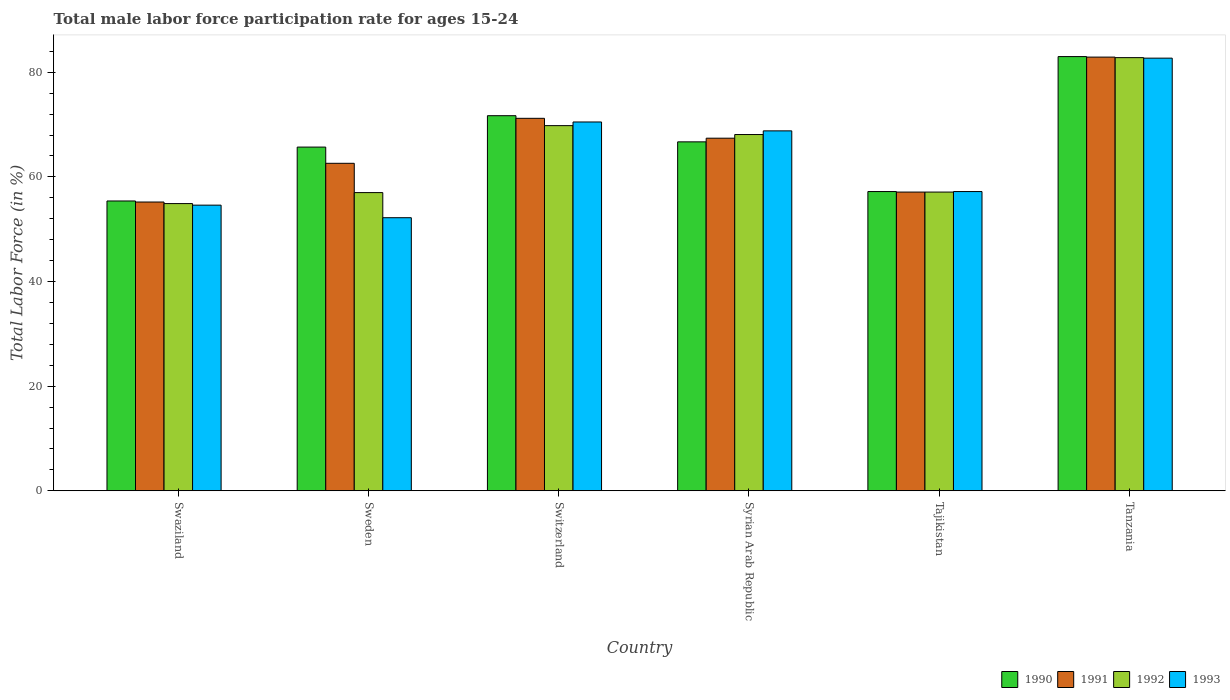What is the label of the 4th group of bars from the left?
Your answer should be very brief. Syrian Arab Republic. What is the male labor force participation rate in 1990 in Tanzania?
Offer a very short reply. 83. Across all countries, what is the maximum male labor force participation rate in 1992?
Make the answer very short. 82.8. Across all countries, what is the minimum male labor force participation rate in 1993?
Ensure brevity in your answer.  52.2. In which country was the male labor force participation rate in 1993 maximum?
Your answer should be compact. Tanzania. In which country was the male labor force participation rate in 1992 minimum?
Provide a short and direct response. Swaziland. What is the total male labor force participation rate in 1993 in the graph?
Offer a terse response. 386. What is the difference between the male labor force participation rate in 1991 in Swaziland and that in Tanzania?
Offer a terse response. -27.7. What is the difference between the male labor force participation rate in 1992 in Tajikistan and the male labor force participation rate in 1993 in Syrian Arab Republic?
Keep it short and to the point. -11.7. What is the average male labor force participation rate in 1990 per country?
Your answer should be very brief. 66.62. What is the difference between the male labor force participation rate of/in 1990 and male labor force participation rate of/in 1991 in Swaziland?
Offer a terse response. 0.2. What is the ratio of the male labor force participation rate in 1990 in Sweden to that in Tanzania?
Your response must be concise. 0.79. Is the male labor force participation rate in 1992 in Sweden less than that in Switzerland?
Provide a short and direct response. Yes. Is the difference between the male labor force participation rate in 1990 in Sweden and Switzerland greater than the difference between the male labor force participation rate in 1991 in Sweden and Switzerland?
Provide a short and direct response. Yes. What is the difference between the highest and the second highest male labor force participation rate in 1991?
Provide a short and direct response. 15.5. What is the difference between the highest and the lowest male labor force participation rate in 1992?
Offer a terse response. 27.9. In how many countries, is the male labor force participation rate in 1992 greater than the average male labor force participation rate in 1992 taken over all countries?
Provide a succinct answer. 3. What does the 3rd bar from the right in Tanzania represents?
Provide a short and direct response. 1991. Are all the bars in the graph horizontal?
Make the answer very short. No. How many countries are there in the graph?
Your answer should be very brief. 6. Are the values on the major ticks of Y-axis written in scientific E-notation?
Give a very brief answer. No. Does the graph contain any zero values?
Offer a very short reply. No. How many legend labels are there?
Your answer should be very brief. 4. How are the legend labels stacked?
Make the answer very short. Horizontal. What is the title of the graph?
Ensure brevity in your answer.  Total male labor force participation rate for ages 15-24. Does "1994" appear as one of the legend labels in the graph?
Your response must be concise. No. What is the Total Labor Force (in %) in 1990 in Swaziland?
Make the answer very short. 55.4. What is the Total Labor Force (in %) in 1991 in Swaziland?
Make the answer very short. 55.2. What is the Total Labor Force (in %) in 1992 in Swaziland?
Ensure brevity in your answer.  54.9. What is the Total Labor Force (in %) in 1993 in Swaziland?
Ensure brevity in your answer.  54.6. What is the Total Labor Force (in %) in 1990 in Sweden?
Offer a terse response. 65.7. What is the Total Labor Force (in %) of 1991 in Sweden?
Your answer should be very brief. 62.6. What is the Total Labor Force (in %) in 1992 in Sweden?
Your answer should be very brief. 57. What is the Total Labor Force (in %) in 1993 in Sweden?
Ensure brevity in your answer.  52.2. What is the Total Labor Force (in %) of 1990 in Switzerland?
Offer a terse response. 71.7. What is the Total Labor Force (in %) in 1991 in Switzerland?
Give a very brief answer. 71.2. What is the Total Labor Force (in %) of 1992 in Switzerland?
Offer a terse response. 69.8. What is the Total Labor Force (in %) of 1993 in Switzerland?
Offer a terse response. 70.5. What is the Total Labor Force (in %) in 1990 in Syrian Arab Republic?
Give a very brief answer. 66.7. What is the Total Labor Force (in %) of 1991 in Syrian Arab Republic?
Provide a short and direct response. 67.4. What is the Total Labor Force (in %) in 1992 in Syrian Arab Republic?
Make the answer very short. 68.1. What is the Total Labor Force (in %) of 1993 in Syrian Arab Republic?
Your response must be concise. 68.8. What is the Total Labor Force (in %) of 1990 in Tajikistan?
Your answer should be very brief. 57.2. What is the Total Labor Force (in %) in 1991 in Tajikistan?
Your answer should be very brief. 57.1. What is the Total Labor Force (in %) in 1992 in Tajikistan?
Ensure brevity in your answer.  57.1. What is the Total Labor Force (in %) in 1993 in Tajikistan?
Offer a very short reply. 57.2. What is the Total Labor Force (in %) of 1990 in Tanzania?
Your response must be concise. 83. What is the Total Labor Force (in %) of 1991 in Tanzania?
Give a very brief answer. 82.9. What is the Total Labor Force (in %) in 1992 in Tanzania?
Provide a short and direct response. 82.8. What is the Total Labor Force (in %) of 1993 in Tanzania?
Offer a terse response. 82.7. Across all countries, what is the maximum Total Labor Force (in %) of 1990?
Provide a succinct answer. 83. Across all countries, what is the maximum Total Labor Force (in %) of 1991?
Provide a short and direct response. 82.9. Across all countries, what is the maximum Total Labor Force (in %) of 1992?
Provide a succinct answer. 82.8. Across all countries, what is the maximum Total Labor Force (in %) of 1993?
Make the answer very short. 82.7. Across all countries, what is the minimum Total Labor Force (in %) of 1990?
Provide a short and direct response. 55.4. Across all countries, what is the minimum Total Labor Force (in %) of 1991?
Offer a very short reply. 55.2. Across all countries, what is the minimum Total Labor Force (in %) of 1992?
Ensure brevity in your answer.  54.9. Across all countries, what is the minimum Total Labor Force (in %) in 1993?
Your response must be concise. 52.2. What is the total Total Labor Force (in %) in 1990 in the graph?
Keep it short and to the point. 399.7. What is the total Total Labor Force (in %) of 1991 in the graph?
Provide a short and direct response. 396.4. What is the total Total Labor Force (in %) in 1992 in the graph?
Your answer should be compact. 389.7. What is the total Total Labor Force (in %) in 1993 in the graph?
Your answer should be very brief. 386. What is the difference between the Total Labor Force (in %) of 1990 in Swaziland and that in Sweden?
Give a very brief answer. -10.3. What is the difference between the Total Labor Force (in %) in 1993 in Swaziland and that in Sweden?
Provide a short and direct response. 2.4. What is the difference between the Total Labor Force (in %) of 1990 in Swaziland and that in Switzerland?
Offer a very short reply. -16.3. What is the difference between the Total Labor Force (in %) of 1991 in Swaziland and that in Switzerland?
Keep it short and to the point. -16. What is the difference between the Total Labor Force (in %) in 1992 in Swaziland and that in Switzerland?
Offer a terse response. -14.9. What is the difference between the Total Labor Force (in %) in 1993 in Swaziland and that in Switzerland?
Provide a succinct answer. -15.9. What is the difference between the Total Labor Force (in %) of 1990 in Swaziland and that in Syrian Arab Republic?
Offer a very short reply. -11.3. What is the difference between the Total Labor Force (in %) of 1991 in Swaziland and that in Syrian Arab Republic?
Your response must be concise. -12.2. What is the difference between the Total Labor Force (in %) of 1992 in Swaziland and that in Syrian Arab Republic?
Your answer should be compact. -13.2. What is the difference between the Total Labor Force (in %) in 1990 in Swaziland and that in Tajikistan?
Provide a short and direct response. -1.8. What is the difference between the Total Labor Force (in %) of 1991 in Swaziland and that in Tajikistan?
Provide a succinct answer. -1.9. What is the difference between the Total Labor Force (in %) in 1992 in Swaziland and that in Tajikistan?
Offer a very short reply. -2.2. What is the difference between the Total Labor Force (in %) of 1993 in Swaziland and that in Tajikistan?
Offer a very short reply. -2.6. What is the difference between the Total Labor Force (in %) in 1990 in Swaziland and that in Tanzania?
Offer a very short reply. -27.6. What is the difference between the Total Labor Force (in %) of 1991 in Swaziland and that in Tanzania?
Offer a terse response. -27.7. What is the difference between the Total Labor Force (in %) of 1992 in Swaziland and that in Tanzania?
Provide a succinct answer. -27.9. What is the difference between the Total Labor Force (in %) of 1993 in Swaziland and that in Tanzania?
Keep it short and to the point. -28.1. What is the difference between the Total Labor Force (in %) in 1992 in Sweden and that in Switzerland?
Keep it short and to the point. -12.8. What is the difference between the Total Labor Force (in %) of 1993 in Sweden and that in Switzerland?
Offer a very short reply. -18.3. What is the difference between the Total Labor Force (in %) of 1990 in Sweden and that in Syrian Arab Republic?
Offer a terse response. -1. What is the difference between the Total Labor Force (in %) of 1991 in Sweden and that in Syrian Arab Republic?
Offer a very short reply. -4.8. What is the difference between the Total Labor Force (in %) of 1993 in Sweden and that in Syrian Arab Republic?
Ensure brevity in your answer.  -16.6. What is the difference between the Total Labor Force (in %) of 1991 in Sweden and that in Tajikistan?
Offer a terse response. 5.5. What is the difference between the Total Labor Force (in %) in 1992 in Sweden and that in Tajikistan?
Your response must be concise. -0.1. What is the difference between the Total Labor Force (in %) in 1990 in Sweden and that in Tanzania?
Offer a very short reply. -17.3. What is the difference between the Total Labor Force (in %) in 1991 in Sweden and that in Tanzania?
Ensure brevity in your answer.  -20.3. What is the difference between the Total Labor Force (in %) of 1992 in Sweden and that in Tanzania?
Your answer should be compact. -25.8. What is the difference between the Total Labor Force (in %) in 1993 in Sweden and that in Tanzania?
Make the answer very short. -30.5. What is the difference between the Total Labor Force (in %) in 1990 in Switzerland and that in Tajikistan?
Give a very brief answer. 14.5. What is the difference between the Total Labor Force (in %) in 1992 in Switzerland and that in Tajikistan?
Offer a terse response. 12.7. What is the difference between the Total Labor Force (in %) in 1992 in Switzerland and that in Tanzania?
Offer a very short reply. -13. What is the difference between the Total Labor Force (in %) of 1990 in Syrian Arab Republic and that in Tanzania?
Your answer should be compact. -16.3. What is the difference between the Total Labor Force (in %) in 1991 in Syrian Arab Republic and that in Tanzania?
Give a very brief answer. -15.5. What is the difference between the Total Labor Force (in %) of 1992 in Syrian Arab Republic and that in Tanzania?
Offer a terse response. -14.7. What is the difference between the Total Labor Force (in %) of 1990 in Tajikistan and that in Tanzania?
Provide a succinct answer. -25.8. What is the difference between the Total Labor Force (in %) in 1991 in Tajikistan and that in Tanzania?
Keep it short and to the point. -25.8. What is the difference between the Total Labor Force (in %) of 1992 in Tajikistan and that in Tanzania?
Make the answer very short. -25.7. What is the difference between the Total Labor Force (in %) of 1993 in Tajikistan and that in Tanzania?
Provide a succinct answer. -25.5. What is the difference between the Total Labor Force (in %) in 1991 in Swaziland and the Total Labor Force (in %) in 1992 in Sweden?
Your answer should be very brief. -1.8. What is the difference between the Total Labor Force (in %) in 1991 in Swaziland and the Total Labor Force (in %) in 1993 in Sweden?
Keep it short and to the point. 3. What is the difference between the Total Labor Force (in %) in 1990 in Swaziland and the Total Labor Force (in %) in 1991 in Switzerland?
Offer a very short reply. -15.8. What is the difference between the Total Labor Force (in %) of 1990 in Swaziland and the Total Labor Force (in %) of 1992 in Switzerland?
Offer a terse response. -14.4. What is the difference between the Total Labor Force (in %) in 1990 in Swaziland and the Total Labor Force (in %) in 1993 in Switzerland?
Give a very brief answer. -15.1. What is the difference between the Total Labor Force (in %) of 1991 in Swaziland and the Total Labor Force (in %) of 1992 in Switzerland?
Your answer should be compact. -14.6. What is the difference between the Total Labor Force (in %) of 1991 in Swaziland and the Total Labor Force (in %) of 1993 in Switzerland?
Your response must be concise. -15.3. What is the difference between the Total Labor Force (in %) in 1992 in Swaziland and the Total Labor Force (in %) in 1993 in Switzerland?
Provide a succinct answer. -15.6. What is the difference between the Total Labor Force (in %) of 1990 in Swaziland and the Total Labor Force (in %) of 1991 in Syrian Arab Republic?
Give a very brief answer. -12. What is the difference between the Total Labor Force (in %) in 1992 in Swaziland and the Total Labor Force (in %) in 1993 in Syrian Arab Republic?
Keep it short and to the point. -13.9. What is the difference between the Total Labor Force (in %) in 1990 in Swaziland and the Total Labor Force (in %) in 1992 in Tajikistan?
Provide a succinct answer. -1.7. What is the difference between the Total Labor Force (in %) of 1990 in Swaziland and the Total Labor Force (in %) of 1993 in Tajikistan?
Make the answer very short. -1.8. What is the difference between the Total Labor Force (in %) of 1992 in Swaziland and the Total Labor Force (in %) of 1993 in Tajikistan?
Your response must be concise. -2.3. What is the difference between the Total Labor Force (in %) in 1990 in Swaziland and the Total Labor Force (in %) in 1991 in Tanzania?
Your answer should be compact. -27.5. What is the difference between the Total Labor Force (in %) of 1990 in Swaziland and the Total Labor Force (in %) of 1992 in Tanzania?
Ensure brevity in your answer.  -27.4. What is the difference between the Total Labor Force (in %) in 1990 in Swaziland and the Total Labor Force (in %) in 1993 in Tanzania?
Keep it short and to the point. -27.3. What is the difference between the Total Labor Force (in %) in 1991 in Swaziland and the Total Labor Force (in %) in 1992 in Tanzania?
Your answer should be compact. -27.6. What is the difference between the Total Labor Force (in %) of 1991 in Swaziland and the Total Labor Force (in %) of 1993 in Tanzania?
Provide a short and direct response. -27.5. What is the difference between the Total Labor Force (in %) in 1992 in Swaziland and the Total Labor Force (in %) in 1993 in Tanzania?
Your response must be concise. -27.8. What is the difference between the Total Labor Force (in %) in 1990 in Sweden and the Total Labor Force (in %) in 1991 in Switzerland?
Your answer should be very brief. -5.5. What is the difference between the Total Labor Force (in %) in 1990 in Sweden and the Total Labor Force (in %) in 1992 in Switzerland?
Ensure brevity in your answer.  -4.1. What is the difference between the Total Labor Force (in %) in 1990 in Sweden and the Total Labor Force (in %) in 1993 in Switzerland?
Your response must be concise. -4.8. What is the difference between the Total Labor Force (in %) in 1991 in Sweden and the Total Labor Force (in %) in 1992 in Switzerland?
Make the answer very short. -7.2. What is the difference between the Total Labor Force (in %) of 1991 in Sweden and the Total Labor Force (in %) of 1993 in Switzerland?
Make the answer very short. -7.9. What is the difference between the Total Labor Force (in %) in 1990 in Sweden and the Total Labor Force (in %) in 1993 in Syrian Arab Republic?
Make the answer very short. -3.1. What is the difference between the Total Labor Force (in %) in 1991 in Sweden and the Total Labor Force (in %) in 1992 in Syrian Arab Republic?
Your response must be concise. -5.5. What is the difference between the Total Labor Force (in %) in 1992 in Sweden and the Total Labor Force (in %) in 1993 in Syrian Arab Republic?
Provide a short and direct response. -11.8. What is the difference between the Total Labor Force (in %) in 1990 in Sweden and the Total Labor Force (in %) in 1991 in Tajikistan?
Your response must be concise. 8.6. What is the difference between the Total Labor Force (in %) of 1990 in Sweden and the Total Labor Force (in %) of 1992 in Tajikistan?
Ensure brevity in your answer.  8.6. What is the difference between the Total Labor Force (in %) of 1990 in Sweden and the Total Labor Force (in %) of 1993 in Tajikistan?
Give a very brief answer. 8.5. What is the difference between the Total Labor Force (in %) of 1991 in Sweden and the Total Labor Force (in %) of 1992 in Tajikistan?
Provide a short and direct response. 5.5. What is the difference between the Total Labor Force (in %) of 1992 in Sweden and the Total Labor Force (in %) of 1993 in Tajikistan?
Give a very brief answer. -0.2. What is the difference between the Total Labor Force (in %) of 1990 in Sweden and the Total Labor Force (in %) of 1991 in Tanzania?
Offer a terse response. -17.2. What is the difference between the Total Labor Force (in %) in 1990 in Sweden and the Total Labor Force (in %) in 1992 in Tanzania?
Keep it short and to the point. -17.1. What is the difference between the Total Labor Force (in %) of 1991 in Sweden and the Total Labor Force (in %) of 1992 in Tanzania?
Keep it short and to the point. -20.2. What is the difference between the Total Labor Force (in %) in 1991 in Sweden and the Total Labor Force (in %) in 1993 in Tanzania?
Your answer should be very brief. -20.1. What is the difference between the Total Labor Force (in %) of 1992 in Sweden and the Total Labor Force (in %) of 1993 in Tanzania?
Your response must be concise. -25.7. What is the difference between the Total Labor Force (in %) of 1990 in Switzerland and the Total Labor Force (in %) of 1992 in Syrian Arab Republic?
Your response must be concise. 3.6. What is the difference between the Total Labor Force (in %) in 1991 in Switzerland and the Total Labor Force (in %) in 1993 in Syrian Arab Republic?
Provide a short and direct response. 2.4. What is the difference between the Total Labor Force (in %) of 1990 in Switzerland and the Total Labor Force (in %) of 1991 in Tajikistan?
Ensure brevity in your answer.  14.6. What is the difference between the Total Labor Force (in %) of 1990 in Switzerland and the Total Labor Force (in %) of 1993 in Tajikistan?
Keep it short and to the point. 14.5. What is the difference between the Total Labor Force (in %) of 1992 in Switzerland and the Total Labor Force (in %) of 1993 in Tajikistan?
Make the answer very short. 12.6. What is the difference between the Total Labor Force (in %) in 1990 in Switzerland and the Total Labor Force (in %) in 1991 in Tanzania?
Your answer should be compact. -11.2. What is the difference between the Total Labor Force (in %) in 1990 in Syrian Arab Republic and the Total Labor Force (in %) in 1991 in Tajikistan?
Provide a succinct answer. 9.6. What is the difference between the Total Labor Force (in %) of 1990 in Syrian Arab Republic and the Total Labor Force (in %) of 1993 in Tajikistan?
Your response must be concise. 9.5. What is the difference between the Total Labor Force (in %) of 1991 in Syrian Arab Republic and the Total Labor Force (in %) of 1993 in Tajikistan?
Provide a short and direct response. 10.2. What is the difference between the Total Labor Force (in %) of 1990 in Syrian Arab Republic and the Total Labor Force (in %) of 1991 in Tanzania?
Give a very brief answer. -16.2. What is the difference between the Total Labor Force (in %) of 1990 in Syrian Arab Republic and the Total Labor Force (in %) of 1992 in Tanzania?
Ensure brevity in your answer.  -16.1. What is the difference between the Total Labor Force (in %) of 1991 in Syrian Arab Republic and the Total Labor Force (in %) of 1992 in Tanzania?
Your answer should be very brief. -15.4. What is the difference between the Total Labor Force (in %) in 1991 in Syrian Arab Republic and the Total Labor Force (in %) in 1993 in Tanzania?
Your response must be concise. -15.3. What is the difference between the Total Labor Force (in %) in 1992 in Syrian Arab Republic and the Total Labor Force (in %) in 1993 in Tanzania?
Offer a very short reply. -14.6. What is the difference between the Total Labor Force (in %) of 1990 in Tajikistan and the Total Labor Force (in %) of 1991 in Tanzania?
Offer a very short reply. -25.7. What is the difference between the Total Labor Force (in %) of 1990 in Tajikistan and the Total Labor Force (in %) of 1992 in Tanzania?
Your answer should be compact. -25.6. What is the difference between the Total Labor Force (in %) in 1990 in Tajikistan and the Total Labor Force (in %) in 1993 in Tanzania?
Offer a terse response. -25.5. What is the difference between the Total Labor Force (in %) in 1991 in Tajikistan and the Total Labor Force (in %) in 1992 in Tanzania?
Your response must be concise. -25.7. What is the difference between the Total Labor Force (in %) in 1991 in Tajikistan and the Total Labor Force (in %) in 1993 in Tanzania?
Provide a short and direct response. -25.6. What is the difference between the Total Labor Force (in %) of 1992 in Tajikistan and the Total Labor Force (in %) of 1993 in Tanzania?
Offer a very short reply. -25.6. What is the average Total Labor Force (in %) in 1990 per country?
Ensure brevity in your answer.  66.62. What is the average Total Labor Force (in %) in 1991 per country?
Offer a terse response. 66.07. What is the average Total Labor Force (in %) of 1992 per country?
Provide a short and direct response. 64.95. What is the average Total Labor Force (in %) of 1993 per country?
Offer a very short reply. 64.33. What is the difference between the Total Labor Force (in %) of 1990 and Total Labor Force (in %) of 1992 in Swaziland?
Your answer should be very brief. 0.5. What is the difference between the Total Labor Force (in %) in 1991 and Total Labor Force (in %) in 1993 in Swaziland?
Make the answer very short. 0.6. What is the difference between the Total Labor Force (in %) of 1990 and Total Labor Force (in %) of 1991 in Sweden?
Ensure brevity in your answer.  3.1. What is the difference between the Total Labor Force (in %) in 1990 and Total Labor Force (in %) in 1992 in Sweden?
Your response must be concise. 8.7. What is the difference between the Total Labor Force (in %) of 1991 and Total Labor Force (in %) of 1993 in Sweden?
Provide a succinct answer. 10.4. What is the difference between the Total Labor Force (in %) in 1990 and Total Labor Force (in %) in 1992 in Switzerland?
Provide a short and direct response. 1.9. What is the difference between the Total Labor Force (in %) in 1990 and Total Labor Force (in %) in 1993 in Switzerland?
Offer a terse response. 1.2. What is the difference between the Total Labor Force (in %) in 1991 and Total Labor Force (in %) in 1993 in Switzerland?
Keep it short and to the point. 0.7. What is the difference between the Total Labor Force (in %) of 1990 and Total Labor Force (in %) of 1993 in Syrian Arab Republic?
Offer a very short reply. -2.1. What is the difference between the Total Labor Force (in %) in 1992 and Total Labor Force (in %) in 1993 in Syrian Arab Republic?
Your answer should be compact. -0.7. What is the difference between the Total Labor Force (in %) in 1990 and Total Labor Force (in %) in 1991 in Tajikistan?
Your response must be concise. 0.1. What is the difference between the Total Labor Force (in %) in 1991 and Total Labor Force (in %) in 1992 in Tajikistan?
Provide a succinct answer. 0. What is the difference between the Total Labor Force (in %) in 1992 and Total Labor Force (in %) in 1993 in Tajikistan?
Give a very brief answer. -0.1. What is the difference between the Total Labor Force (in %) of 1990 and Total Labor Force (in %) of 1991 in Tanzania?
Your answer should be compact. 0.1. What is the difference between the Total Labor Force (in %) in 1991 and Total Labor Force (in %) in 1993 in Tanzania?
Provide a short and direct response. 0.2. What is the ratio of the Total Labor Force (in %) of 1990 in Swaziland to that in Sweden?
Keep it short and to the point. 0.84. What is the ratio of the Total Labor Force (in %) of 1991 in Swaziland to that in Sweden?
Ensure brevity in your answer.  0.88. What is the ratio of the Total Labor Force (in %) in 1992 in Swaziland to that in Sweden?
Provide a short and direct response. 0.96. What is the ratio of the Total Labor Force (in %) of 1993 in Swaziland to that in Sweden?
Offer a very short reply. 1.05. What is the ratio of the Total Labor Force (in %) in 1990 in Swaziland to that in Switzerland?
Provide a succinct answer. 0.77. What is the ratio of the Total Labor Force (in %) in 1991 in Swaziland to that in Switzerland?
Ensure brevity in your answer.  0.78. What is the ratio of the Total Labor Force (in %) in 1992 in Swaziland to that in Switzerland?
Provide a succinct answer. 0.79. What is the ratio of the Total Labor Force (in %) in 1993 in Swaziland to that in Switzerland?
Give a very brief answer. 0.77. What is the ratio of the Total Labor Force (in %) in 1990 in Swaziland to that in Syrian Arab Republic?
Keep it short and to the point. 0.83. What is the ratio of the Total Labor Force (in %) of 1991 in Swaziland to that in Syrian Arab Republic?
Provide a short and direct response. 0.82. What is the ratio of the Total Labor Force (in %) in 1992 in Swaziland to that in Syrian Arab Republic?
Provide a short and direct response. 0.81. What is the ratio of the Total Labor Force (in %) in 1993 in Swaziland to that in Syrian Arab Republic?
Give a very brief answer. 0.79. What is the ratio of the Total Labor Force (in %) of 1990 in Swaziland to that in Tajikistan?
Your answer should be very brief. 0.97. What is the ratio of the Total Labor Force (in %) in 1991 in Swaziland to that in Tajikistan?
Offer a terse response. 0.97. What is the ratio of the Total Labor Force (in %) in 1992 in Swaziland to that in Tajikistan?
Provide a succinct answer. 0.96. What is the ratio of the Total Labor Force (in %) in 1993 in Swaziland to that in Tajikistan?
Offer a terse response. 0.95. What is the ratio of the Total Labor Force (in %) in 1990 in Swaziland to that in Tanzania?
Offer a very short reply. 0.67. What is the ratio of the Total Labor Force (in %) of 1991 in Swaziland to that in Tanzania?
Offer a very short reply. 0.67. What is the ratio of the Total Labor Force (in %) of 1992 in Swaziland to that in Tanzania?
Your answer should be compact. 0.66. What is the ratio of the Total Labor Force (in %) of 1993 in Swaziland to that in Tanzania?
Your answer should be compact. 0.66. What is the ratio of the Total Labor Force (in %) of 1990 in Sweden to that in Switzerland?
Provide a short and direct response. 0.92. What is the ratio of the Total Labor Force (in %) of 1991 in Sweden to that in Switzerland?
Offer a terse response. 0.88. What is the ratio of the Total Labor Force (in %) of 1992 in Sweden to that in Switzerland?
Keep it short and to the point. 0.82. What is the ratio of the Total Labor Force (in %) of 1993 in Sweden to that in Switzerland?
Give a very brief answer. 0.74. What is the ratio of the Total Labor Force (in %) of 1990 in Sweden to that in Syrian Arab Republic?
Make the answer very short. 0.98. What is the ratio of the Total Labor Force (in %) of 1991 in Sweden to that in Syrian Arab Republic?
Offer a terse response. 0.93. What is the ratio of the Total Labor Force (in %) in 1992 in Sweden to that in Syrian Arab Republic?
Offer a very short reply. 0.84. What is the ratio of the Total Labor Force (in %) of 1993 in Sweden to that in Syrian Arab Republic?
Offer a very short reply. 0.76. What is the ratio of the Total Labor Force (in %) in 1990 in Sweden to that in Tajikistan?
Your response must be concise. 1.15. What is the ratio of the Total Labor Force (in %) in 1991 in Sweden to that in Tajikistan?
Your response must be concise. 1.1. What is the ratio of the Total Labor Force (in %) of 1993 in Sweden to that in Tajikistan?
Keep it short and to the point. 0.91. What is the ratio of the Total Labor Force (in %) of 1990 in Sweden to that in Tanzania?
Give a very brief answer. 0.79. What is the ratio of the Total Labor Force (in %) of 1991 in Sweden to that in Tanzania?
Provide a short and direct response. 0.76. What is the ratio of the Total Labor Force (in %) of 1992 in Sweden to that in Tanzania?
Give a very brief answer. 0.69. What is the ratio of the Total Labor Force (in %) of 1993 in Sweden to that in Tanzania?
Make the answer very short. 0.63. What is the ratio of the Total Labor Force (in %) of 1990 in Switzerland to that in Syrian Arab Republic?
Ensure brevity in your answer.  1.07. What is the ratio of the Total Labor Force (in %) of 1991 in Switzerland to that in Syrian Arab Republic?
Make the answer very short. 1.06. What is the ratio of the Total Labor Force (in %) of 1992 in Switzerland to that in Syrian Arab Republic?
Ensure brevity in your answer.  1.02. What is the ratio of the Total Labor Force (in %) in 1993 in Switzerland to that in Syrian Arab Republic?
Make the answer very short. 1.02. What is the ratio of the Total Labor Force (in %) of 1990 in Switzerland to that in Tajikistan?
Give a very brief answer. 1.25. What is the ratio of the Total Labor Force (in %) of 1991 in Switzerland to that in Tajikistan?
Ensure brevity in your answer.  1.25. What is the ratio of the Total Labor Force (in %) in 1992 in Switzerland to that in Tajikistan?
Your response must be concise. 1.22. What is the ratio of the Total Labor Force (in %) in 1993 in Switzerland to that in Tajikistan?
Your answer should be very brief. 1.23. What is the ratio of the Total Labor Force (in %) in 1990 in Switzerland to that in Tanzania?
Your answer should be compact. 0.86. What is the ratio of the Total Labor Force (in %) of 1991 in Switzerland to that in Tanzania?
Provide a succinct answer. 0.86. What is the ratio of the Total Labor Force (in %) in 1992 in Switzerland to that in Tanzania?
Your answer should be very brief. 0.84. What is the ratio of the Total Labor Force (in %) in 1993 in Switzerland to that in Tanzania?
Offer a terse response. 0.85. What is the ratio of the Total Labor Force (in %) of 1990 in Syrian Arab Republic to that in Tajikistan?
Keep it short and to the point. 1.17. What is the ratio of the Total Labor Force (in %) of 1991 in Syrian Arab Republic to that in Tajikistan?
Ensure brevity in your answer.  1.18. What is the ratio of the Total Labor Force (in %) of 1992 in Syrian Arab Republic to that in Tajikistan?
Your answer should be compact. 1.19. What is the ratio of the Total Labor Force (in %) of 1993 in Syrian Arab Republic to that in Tajikistan?
Offer a terse response. 1.2. What is the ratio of the Total Labor Force (in %) in 1990 in Syrian Arab Republic to that in Tanzania?
Make the answer very short. 0.8. What is the ratio of the Total Labor Force (in %) of 1991 in Syrian Arab Republic to that in Tanzania?
Offer a very short reply. 0.81. What is the ratio of the Total Labor Force (in %) in 1992 in Syrian Arab Republic to that in Tanzania?
Provide a short and direct response. 0.82. What is the ratio of the Total Labor Force (in %) in 1993 in Syrian Arab Republic to that in Tanzania?
Provide a succinct answer. 0.83. What is the ratio of the Total Labor Force (in %) in 1990 in Tajikistan to that in Tanzania?
Keep it short and to the point. 0.69. What is the ratio of the Total Labor Force (in %) of 1991 in Tajikistan to that in Tanzania?
Your answer should be compact. 0.69. What is the ratio of the Total Labor Force (in %) of 1992 in Tajikistan to that in Tanzania?
Your response must be concise. 0.69. What is the ratio of the Total Labor Force (in %) in 1993 in Tajikistan to that in Tanzania?
Provide a short and direct response. 0.69. What is the difference between the highest and the second highest Total Labor Force (in %) in 1990?
Your answer should be very brief. 11.3. What is the difference between the highest and the second highest Total Labor Force (in %) in 1991?
Your answer should be very brief. 11.7. What is the difference between the highest and the second highest Total Labor Force (in %) in 1992?
Provide a short and direct response. 13. What is the difference between the highest and the second highest Total Labor Force (in %) in 1993?
Ensure brevity in your answer.  12.2. What is the difference between the highest and the lowest Total Labor Force (in %) in 1990?
Your response must be concise. 27.6. What is the difference between the highest and the lowest Total Labor Force (in %) of 1991?
Your answer should be very brief. 27.7. What is the difference between the highest and the lowest Total Labor Force (in %) of 1992?
Give a very brief answer. 27.9. What is the difference between the highest and the lowest Total Labor Force (in %) of 1993?
Make the answer very short. 30.5. 